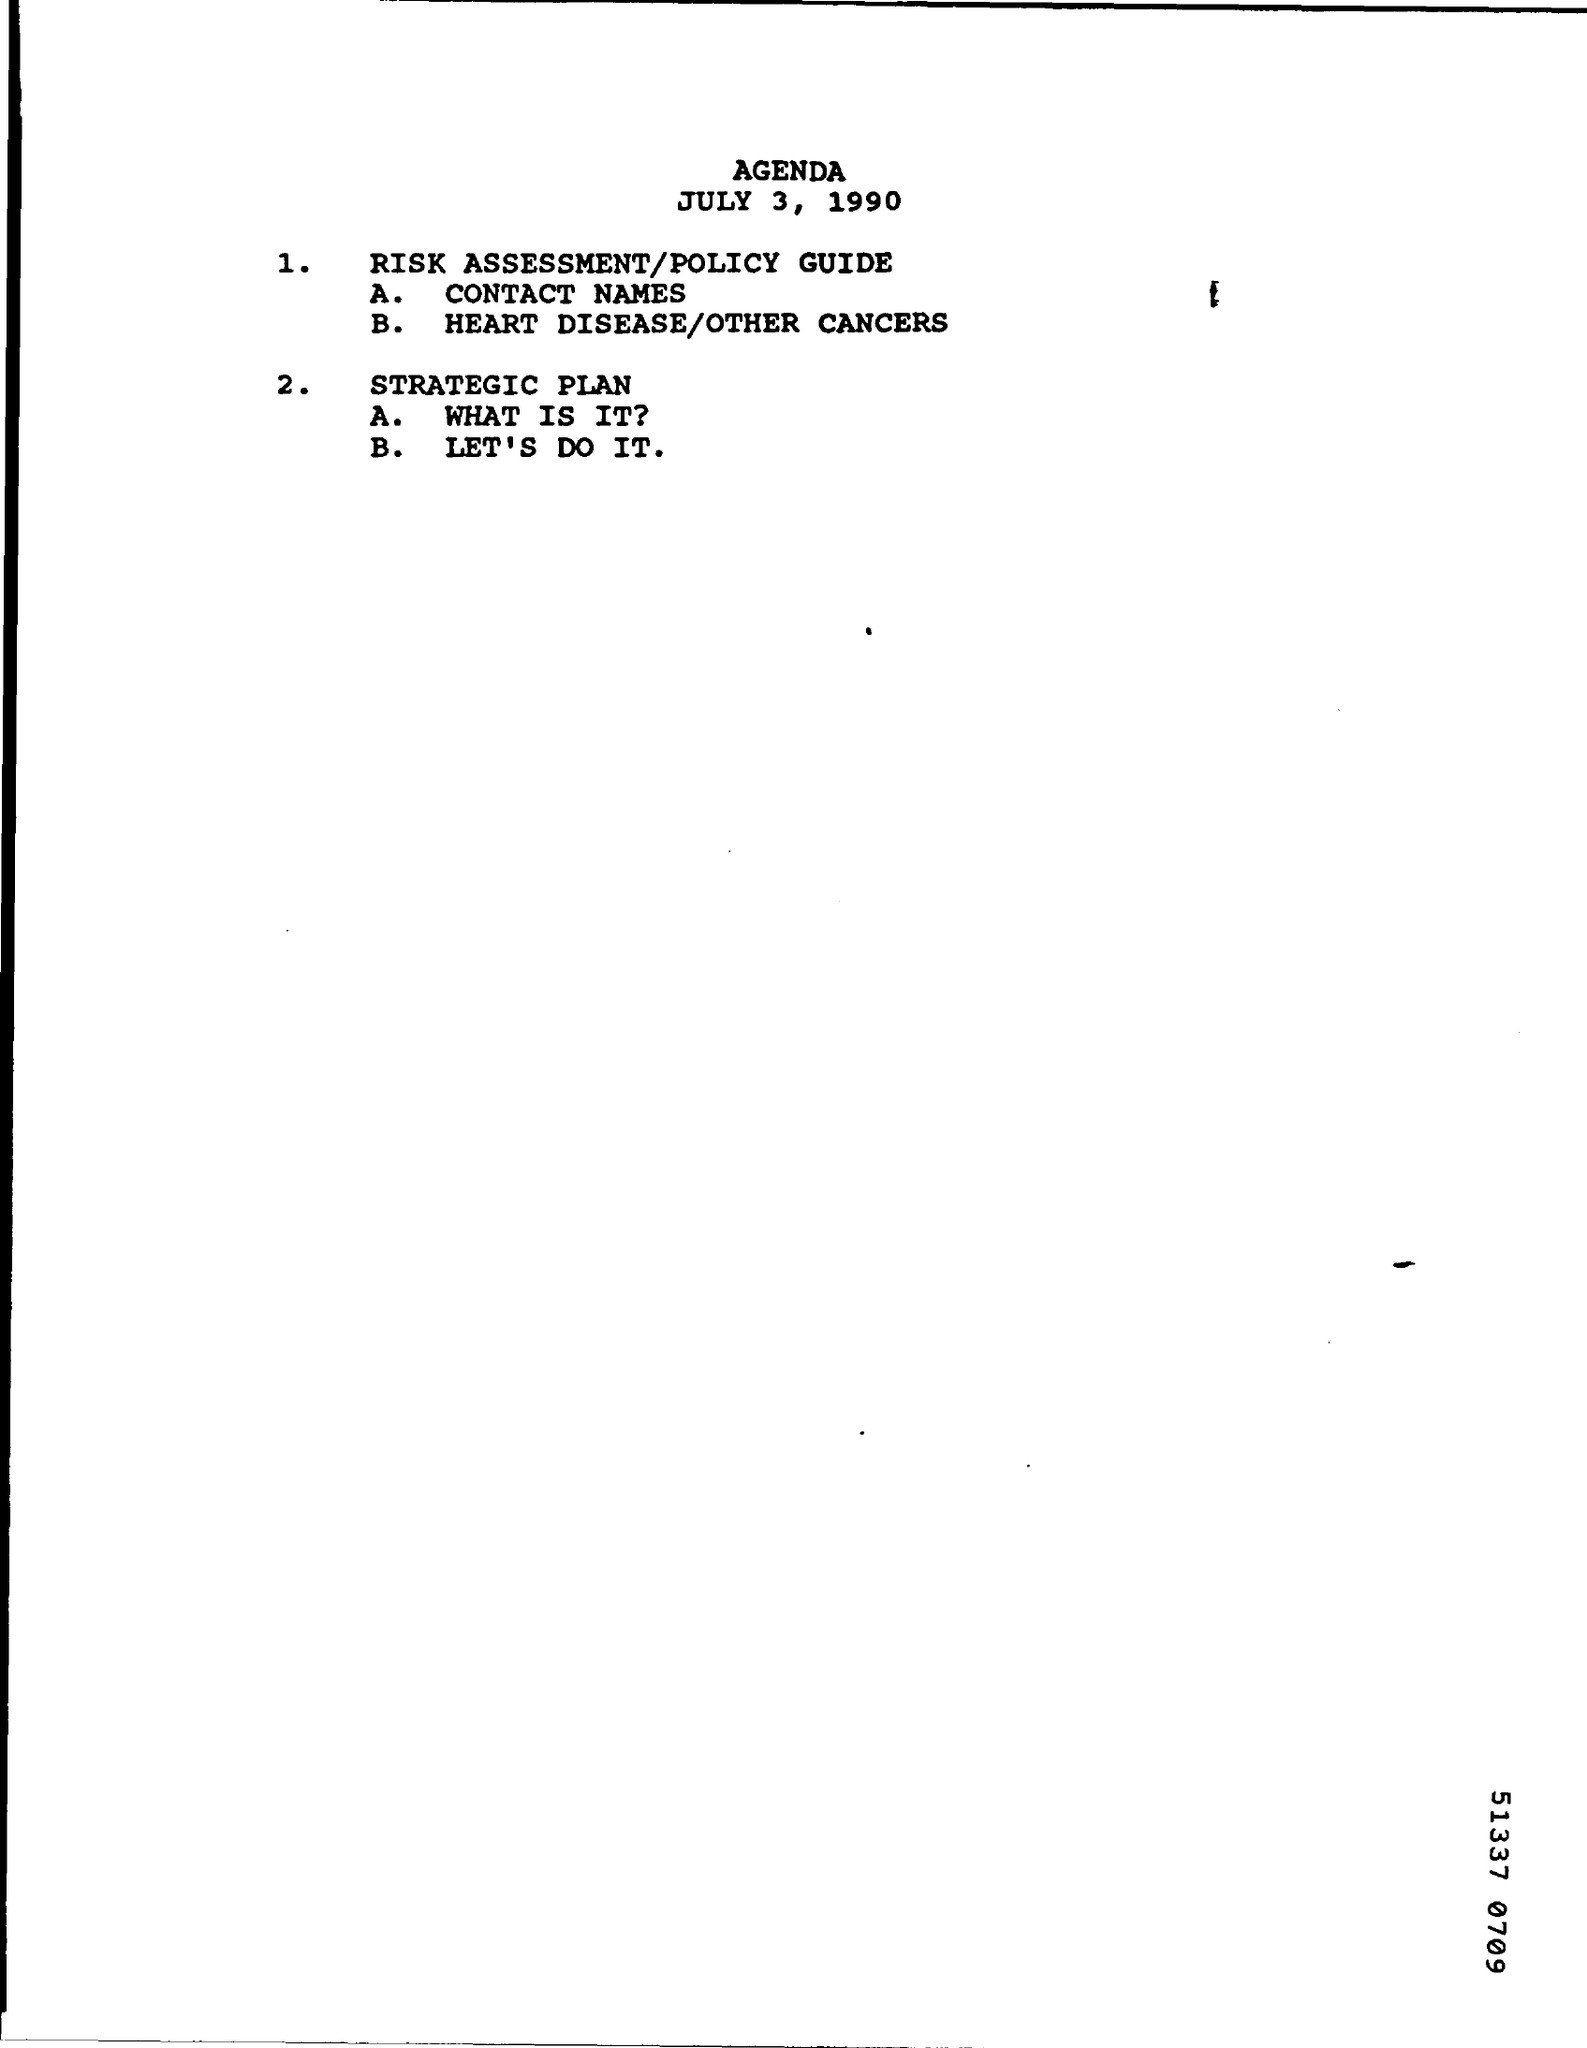Identify some key points in this picture. The title of the document is Agenda. 